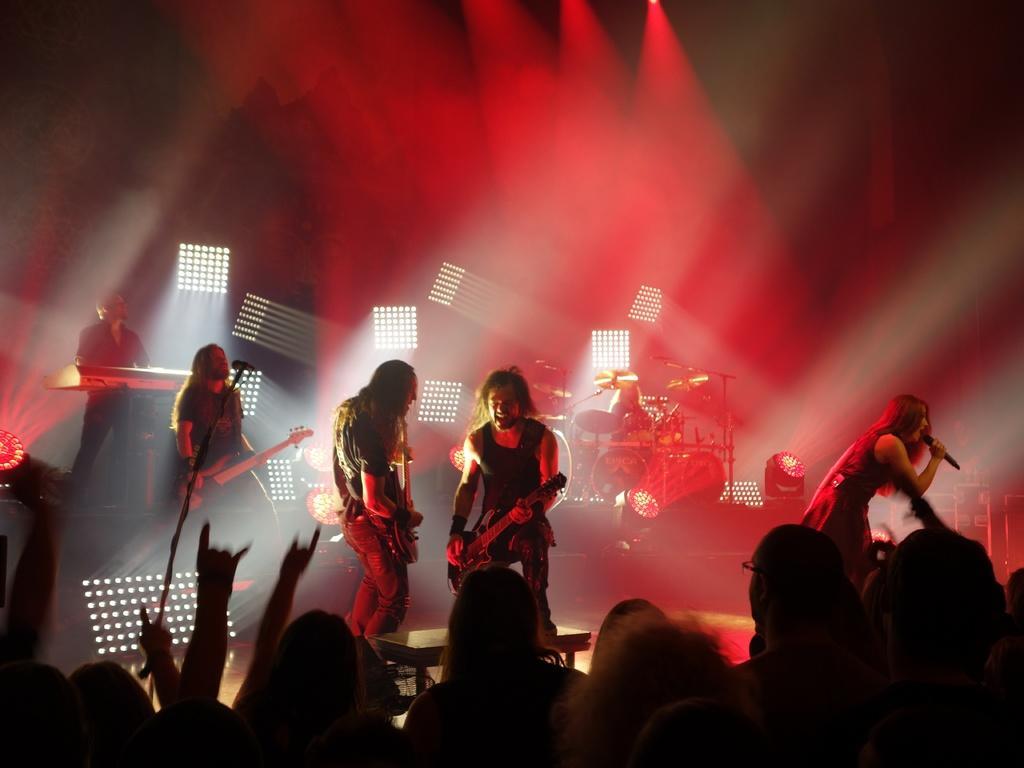Please provide a concise description of this image. This picture is of inside. In the foreground there are group of people standing. On the right there is a woman standing, holding a microphone and singing. In the center there are two persons standing and playing guitar. On the left there is a man standing and playing guitar. There is a microphone attached to the stand and there is a person standing and seems to be playing a musical instrument. In the background we can see the musical instruments, focusing lights. 